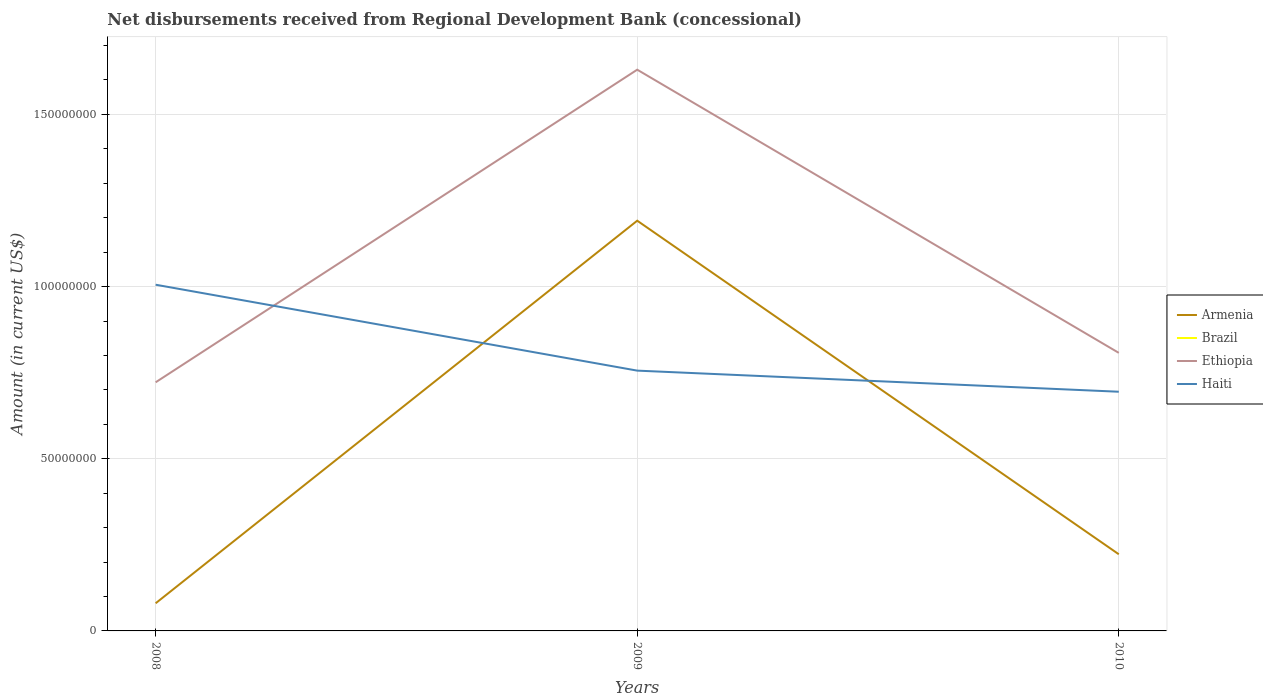How many different coloured lines are there?
Offer a very short reply. 3. Across all years, what is the maximum amount of disbursements received from Regional Development Bank in Ethiopia?
Provide a succinct answer. 7.22e+07. What is the total amount of disbursements received from Regional Development Bank in Haiti in the graph?
Your answer should be very brief. 2.50e+07. What is the difference between the highest and the second highest amount of disbursements received from Regional Development Bank in Armenia?
Offer a very short reply. 1.11e+08. Is the amount of disbursements received from Regional Development Bank in Haiti strictly greater than the amount of disbursements received from Regional Development Bank in Armenia over the years?
Give a very brief answer. No. What is the difference between two consecutive major ticks on the Y-axis?
Ensure brevity in your answer.  5.00e+07. Are the values on the major ticks of Y-axis written in scientific E-notation?
Make the answer very short. No. Where does the legend appear in the graph?
Provide a short and direct response. Center right. How many legend labels are there?
Offer a very short reply. 4. What is the title of the graph?
Offer a very short reply. Net disbursements received from Regional Development Bank (concessional). What is the Amount (in current US$) in Armenia in 2008?
Your answer should be very brief. 8.03e+06. What is the Amount (in current US$) in Brazil in 2008?
Give a very brief answer. 0. What is the Amount (in current US$) of Ethiopia in 2008?
Your answer should be very brief. 7.22e+07. What is the Amount (in current US$) in Haiti in 2008?
Make the answer very short. 1.01e+08. What is the Amount (in current US$) in Armenia in 2009?
Provide a succinct answer. 1.19e+08. What is the Amount (in current US$) in Brazil in 2009?
Make the answer very short. 0. What is the Amount (in current US$) of Ethiopia in 2009?
Your answer should be compact. 1.63e+08. What is the Amount (in current US$) in Haiti in 2009?
Offer a terse response. 7.56e+07. What is the Amount (in current US$) in Armenia in 2010?
Give a very brief answer. 2.23e+07. What is the Amount (in current US$) in Ethiopia in 2010?
Your answer should be very brief. 8.08e+07. What is the Amount (in current US$) of Haiti in 2010?
Provide a short and direct response. 6.95e+07. Across all years, what is the maximum Amount (in current US$) in Armenia?
Make the answer very short. 1.19e+08. Across all years, what is the maximum Amount (in current US$) of Ethiopia?
Give a very brief answer. 1.63e+08. Across all years, what is the maximum Amount (in current US$) of Haiti?
Make the answer very short. 1.01e+08. Across all years, what is the minimum Amount (in current US$) of Armenia?
Your answer should be compact. 8.03e+06. Across all years, what is the minimum Amount (in current US$) in Ethiopia?
Keep it short and to the point. 7.22e+07. Across all years, what is the minimum Amount (in current US$) in Haiti?
Provide a succinct answer. 6.95e+07. What is the total Amount (in current US$) in Armenia in the graph?
Provide a short and direct response. 1.49e+08. What is the total Amount (in current US$) of Ethiopia in the graph?
Provide a succinct answer. 3.16e+08. What is the total Amount (in current US$) of Haiti in the graph?
Give a very brief answer. 2.46e+08. What is the difference between the Amount (in current US$) of Armenia in 2008 and that in 2009?
Make the answer very short. -1.11e+08. What is the difference between the Amount (in current US$) in Ethiopia in 2008 and that in 2009?
Offer a terse response. -9.08e+07. What is the difference between the Amount (in current US$) of Haiti in 2008 and that in 2009?
Give a very brief answer. 2.50e+07. What is the difference between the Amount (in current US$) in Armenia in 2008 and that in 2010?
Ensure brevity in your answer.  -1.42e+07. What is the difference between the Amount (in current US$) of Ethiopia in 2008 and that in 2010?
Offer a very short reply. -8.55e+06. What is the difference between the Amount (in current US$) of Haiti in 2008 and that in 2010?
Ensure brevity in your answer.  3.11e+07. What is the difference between the Amount (in current US$) in Armenia in 2009 and that in 2010?
Your answer should be very brief. 9.69e+07. What is the difference between the Amount (in current US$) of Ethiopia in 2009 and that in 2010?
Provide a short and direct response. 8.22e+07. What is the difference between the Amount (in current US$) in Haiti in 2009 and that in 2010?
Provide a succinct answer. 6.13e+06. What is the difference between the Amount (in current US$) in Armenia in 2008 and the Amount (in current US$) in Ethiopia in 2009?
Your response must be concise. -1.55e+08. What is the difference between the Amount (in current US$) of Armenia in 2008 and the Amount (in current US$) of Haiti in 2009?
Your answer should be very brief. -6.76e+07. What is the difference between the Amount (in current US$) in Ethiopia in 2008 and the Amount (in current US$) in Haiti in 2009?
Keep it short and to the point. -3.39e+06. What is the difference between the Amount (in current US$) in Armenia in 2008 and the Amount (in current US$) in Ethiopia in 2010?
Keep it short and to the point. -7.27e+07. What is the difference between the Amount (in current US$) in Armenia in 2008 and the Amount (in current US$) in Haiti in 2010?
Ensure brevity in your answer.  -6.14e+07. What is the difference between the Amount (in current US$) in Ethiopia in 2008 and the Amount (in current US$) in Haiti in 2010?
Offer a very short reply. 2.74e+06. What is the difference between the Amount (in current US$) of Armenia in 2009 and the Amount (in current US$) of Ethiopia in 2010?
Make the answer very short. 3.84e+07. What is the difference between the Amount (in current US$) in Armenia in 2009 and the Amount (in current US$) in Haiti in 2010?
Keep it short and to the point. 4.97e+07. What is the difference between the Amount (in current US$) in Ethiopia in 2009 and the Amount (in current US$) in Haiti in 2010?
Keep it short and to the point. 9.35e+07. What is the average Amount (in current US$) in Armenia per year?
Your answer should be very brief. 4.98e+07. What is the average Amount (in current US$) of Brazil per year?
Your response must be concise. 0. What is the average Amount (in current US$) of Ethiopia per year?
Keep it short and to the point. 1.05e+08. What is the average Amount (in current US$) of Haiti per year?
Offer a very short reply. 8.19e+07. In the year 2008, what is the difference between the Amount (in current US$) in Armenia and Amount (in current US$) in Ethiopia?
Ensure brevity in your answer.  -6.42e+07. In the year 2008, what is the difference between the Amount (in current US$) in Armenia and Amount (in current US$) in Haiti?
Your answer should be compact. -9.25e+07. In the year 2008, what is the difference between the Amount (in current US$) in Ethiopia and Amount (in current US$) in Haiti?
Give a very brief answer. -2.83e+07. In the year 2009, what is the difference between the Amount (in current US$) in Armenia and Amount (in current US$) in Ethiopia?
Provide a succinct answer. -4.39e+07. In the year 2009, what is the difference between the Amount (in current US$) of Armenia and Amount (in current US$) of Haiti?
Provide a short and direct response. 4.35e+07. In the year 2009, what is the difference between the Amount (in current US$) in Ethiopia and Amount (in current US$) in Haiti?
Provide a succinct answer. 8.74e+07. In the year 2010, what is the difference between the Amount (in current US$) of Armenia and Amount (in current US$) of Ethiopia?
Make the answer very short. -5.85e+07. In the year 2010, what is the difference between the Amount (in current US$) in Armenia and Amount (in current US$) in Haiti?
Keep it short and to the point. -4.72e+07. In the year 2010, what is the difference between the Amount (in current US$) of Ethiopia and Amount (in current US$) of Haiti?
Offer a terse response. 1.13e+07. What is the ratio of the Amount (in current US$) of Armenia in 2008 to that in 2009?
Keep it short and to the point. 0.07. What is the ratio of the Amount (in current US$) of Ethiopia in 2008 to that in 2009?
Your response must be concise. 0.44. What is the ratio of the Amount (in current US$) in Haiti in 2008 to that in 2009?
Keep it short and to the point. 1.33. What is the ratio of the Amount (in current US$) in Armenia in 2008 to that in 2010?
Provide a succinct answer. 0.36. What is the ratio of the Amount (in current US$) in Ethiopia in 2008 to that in 2010?
Give a very brief answer. 0.89. What is the ratio of the Amount (in current US$) in Haiti in 2008 to that in 2010?
Ensure brevity in your answer.  1.45. What is the ratio of the Amount (in current US$) of Armenia in 2009 to that in 2010?
Your response must be concise. 5.35. What is the ratio of the Amount (in current US$) of Ethiopia in 2009 to that in 2010?
Give a very brief answer. 2.02. What is the ratio of the Amount (in current US$) of Haiti in 2009 to that in 2010?
Offer a very short reply. 1.09. What is the difference between the highest and the second highest Amount (in current US$) of Armenia?
Provide a short and direct response. 9.69e+07. What is the difference between the highest and the second highest Amount (in current US$) of Ethiopia?
Your answer should be very brief. 8.22e+07. What is the difference between the highest and the second highest Amount (in current US$) of Haiti?
Give a very brief answer. 2.50e+07. What is the difference between the highest and the lowest Amount (in current US$) in Armenia?
Give a very brief answer. 1.11e+08. What is the difference between the highest and the lowest Amount (in current US$) in Ethiopia?
Offer a terse response. 9.08e+07. What is the difference between the highest and the lowest Amount (in current US$) in Haiti?
Provide a short and direct response. 3.11e+07. 